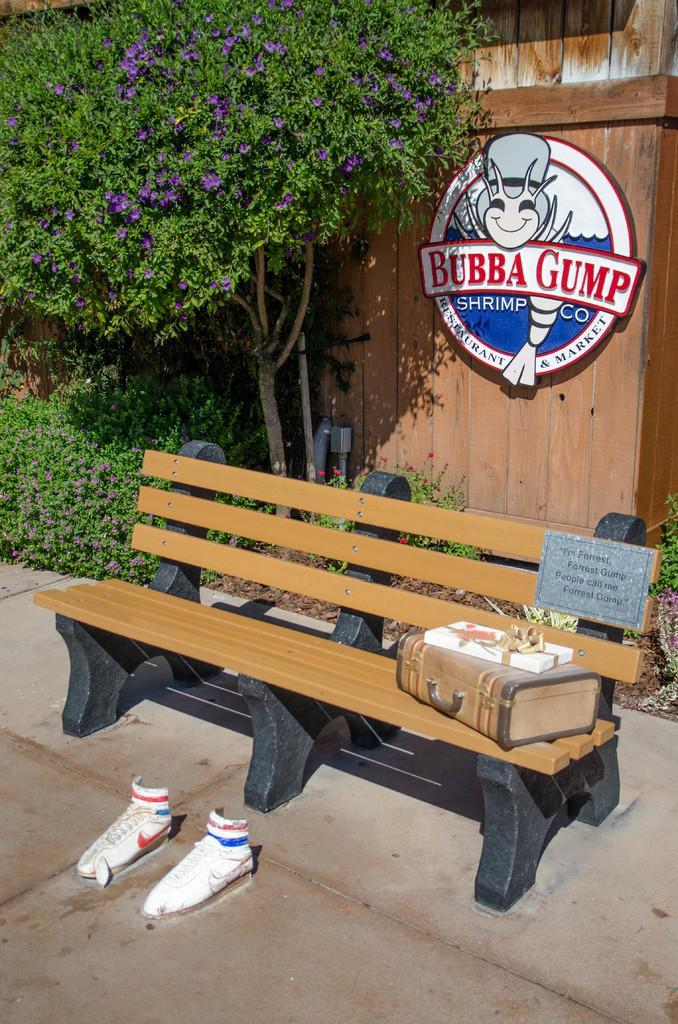Describe this image in one or two sentences. In the center of the image, we can see boxes on the bench and in the background, there is a tree and some plants and we can see a board on the wooden wall. At the bottom, there are shoes on the road. 